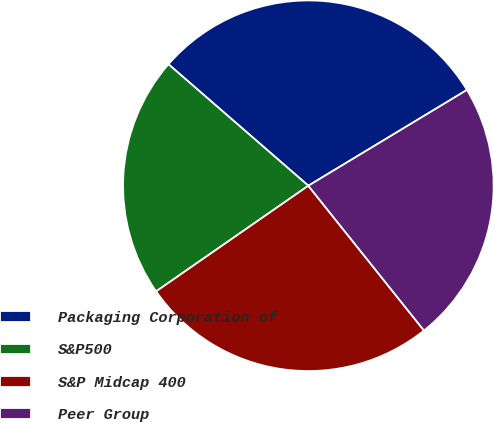<chart> <loc_0><loc_0><loc_500><loc_500><pie_chart><fcel>Packaging Corporation of<fcel>S&P500<fcel>S&P Midcap 400<fcel>Peer Group<nl><fcel>29.97%<fcel>21.04%<fcel>26.07%<fcel>22.92%<nl></chart> 